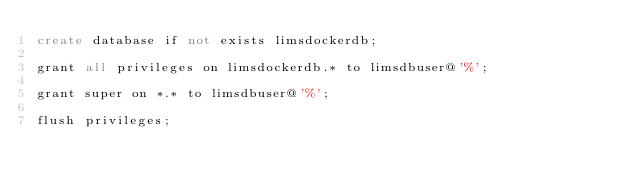Convert code to text. <code><loc_0><loc_0><loc_500><loc_500><_SQL_>create database if not exists limsdockerdb;

grant all privileges on limsdockerdb.* to limsdbuser@'%';

grant super on *.* to limsdbuser@'%';

flush privileges;
</code> 